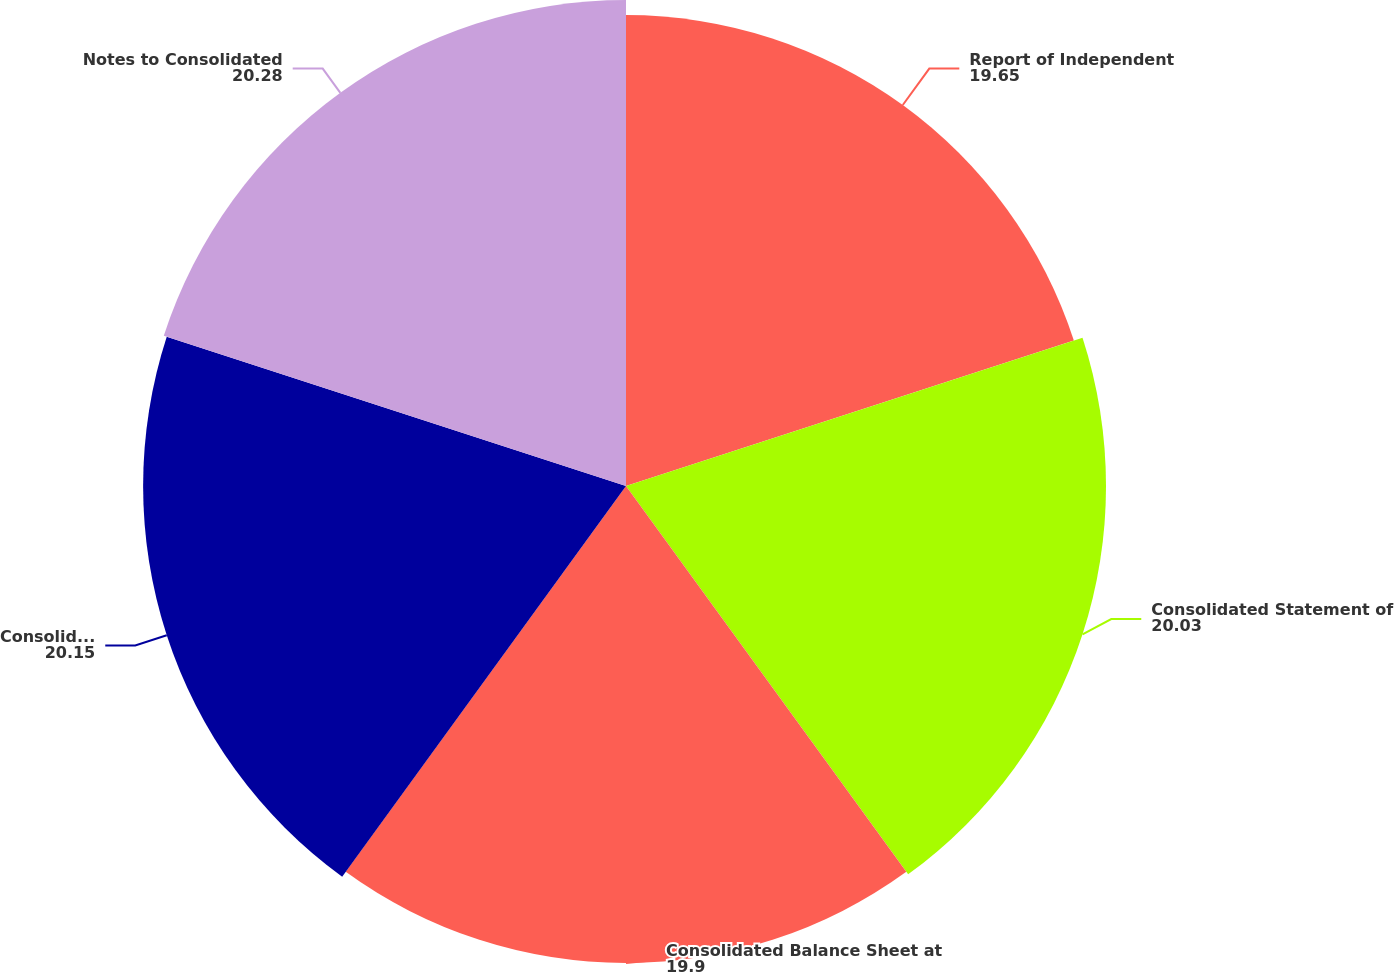Convert chart to OTSL. <chart><loc_0><loc_0><loc_500><loc_500><pie_chart><fcel>Report of Independent<fcel>Consolidated Statement of<fcel>Consolidated Balance Sheet at<fcel>Consolidated Statement of Cash<fcel>Notes to Consolidated<nl><fcel>19.65%<fcel>20.03%<fcel>19.9%<fcel>20.15%<fcel>20.28%<nl></chart> 